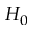<formula> <loc_0><loc_0><loc_500><loc_500>H _ { 0 }</formula> 